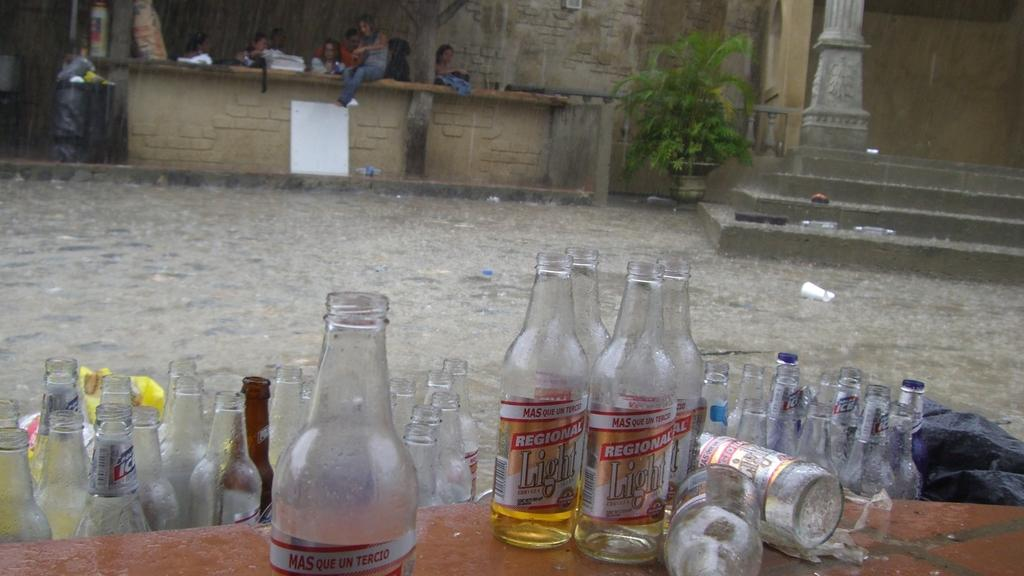Provide a one-sentence caption for the provided image. empty bottles of Regional Light cerveza on an outside table. 